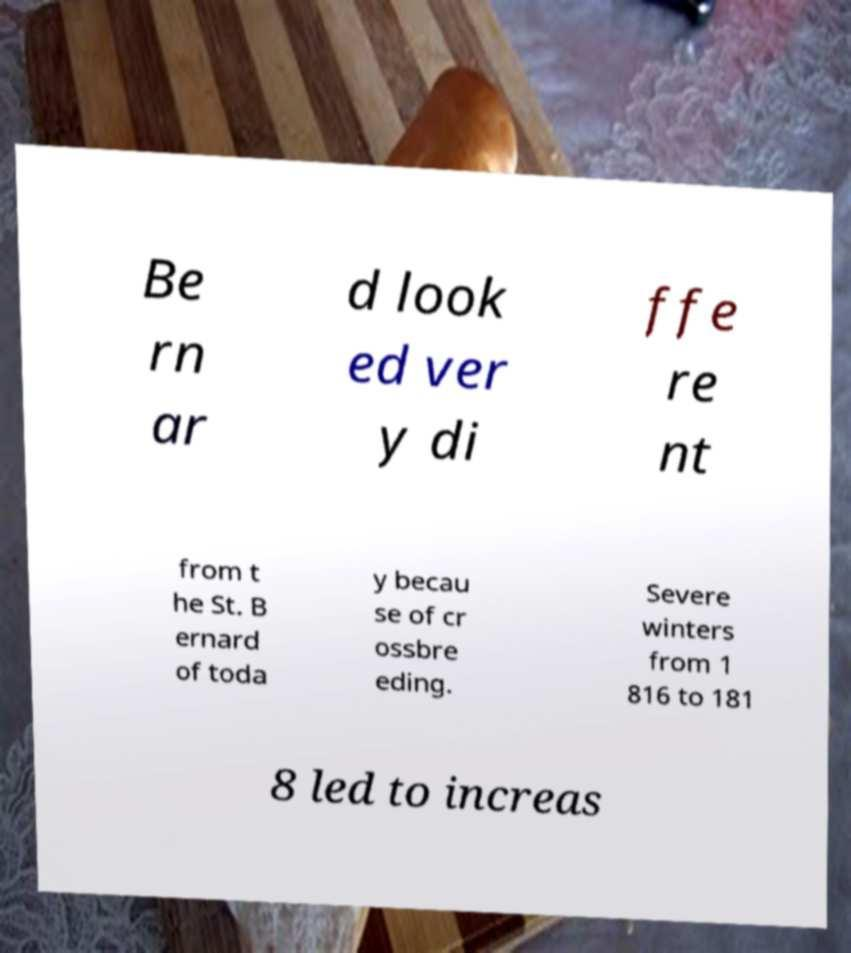What messages or text are displayed in this image? I need them in a readable, typed format. Be rn ar d look ed ver y di ffe re nt from t he St. B ernard of toda y becau se of cr ossbre eding. Severe winters from 1 816 to 181 8 led to increas 